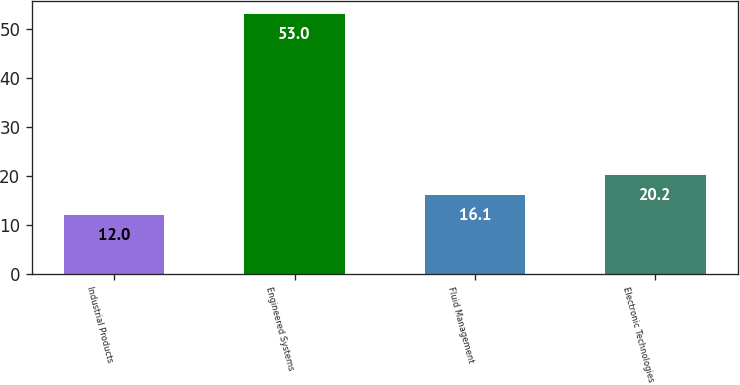<chart> <loc_0><loc_0><loc_500><loc_500><bar_chart><fcel>Industrial Products<fcel>Engineered Systems<fcel>Fluid Management<fcel>Electronic Technologies<nl><fcel>12<fcel>53<fcel>16.1<fcel>20.2<nl></chart> 